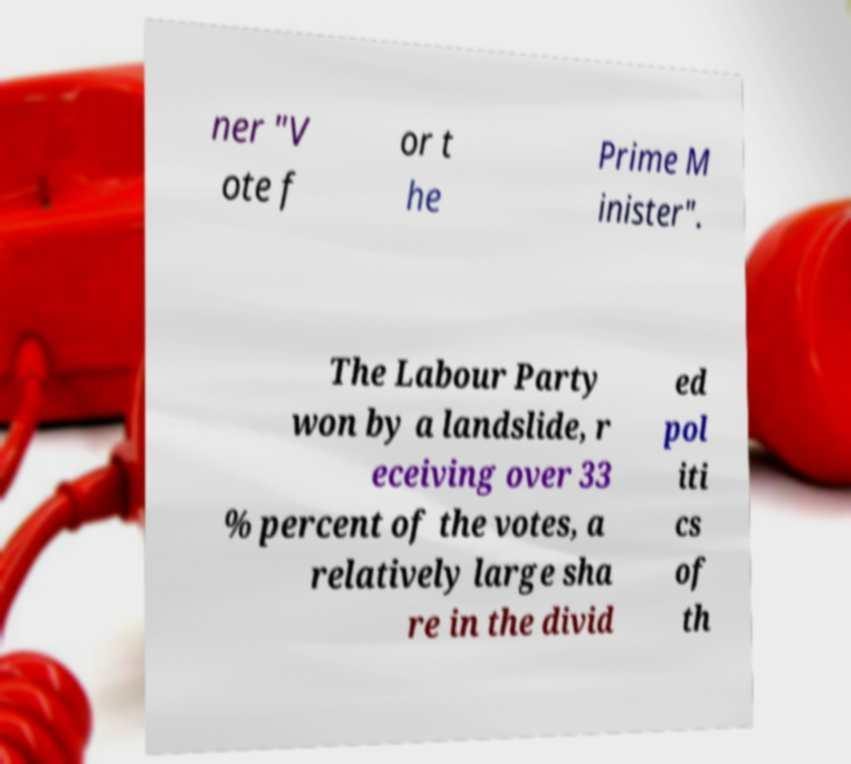Please identify and transcribe the text found in this image. ner "V ote f or t he Prime M inister". The Labour Party won by a landslide, r eceiving over 33 % percent of the votes, a relatively large sha re in the divid ed pol iti cs of th 